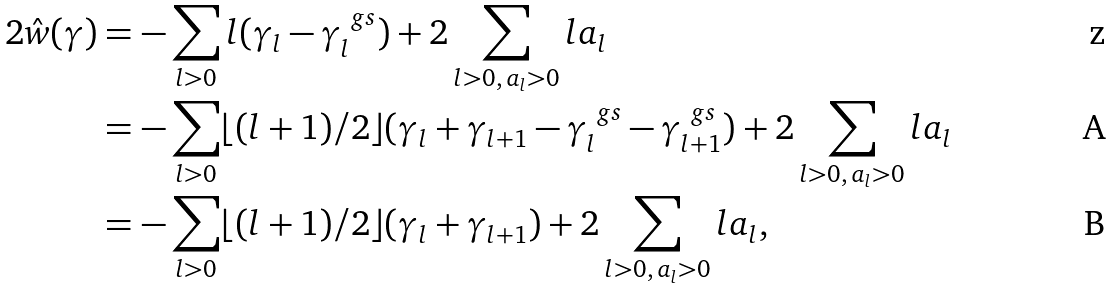<formula> <loc_0><loc_0><loc_500><loc_500>2 \hat { w } ( \gamma ) & = - \sum _ { l > 0 } l ( \gamma _ { l } - \gamma ^ { \ g s } _ { l } ) + 2 \sum _ { l > 0 , \, a _ { l } > 0 } l a _ { l } \\ & = - \sum _ { l > 0 } \lfloor ( l + 1 ) / 2 \rfloor ( \gamma _ { l } + \gamma _ { l + 1 } - \gamma ^ { \ g s } _ { l } - \gamma ^ { \ g s } _ { l + 1 } ) + 2 \sum _ { l > 0 , \, a _ { l } > 0 } l a _ { l } \\ & = - \sum _ { l > 0 } \lfloor ( l + 1 ) / 2 \rfloor ( \gamma _ { l } + \gamma _ { l + 1 } ) + 2 \sum _ { l > 0 , \, a _ { l } > 0 } l a _ { l } ,</formula> 